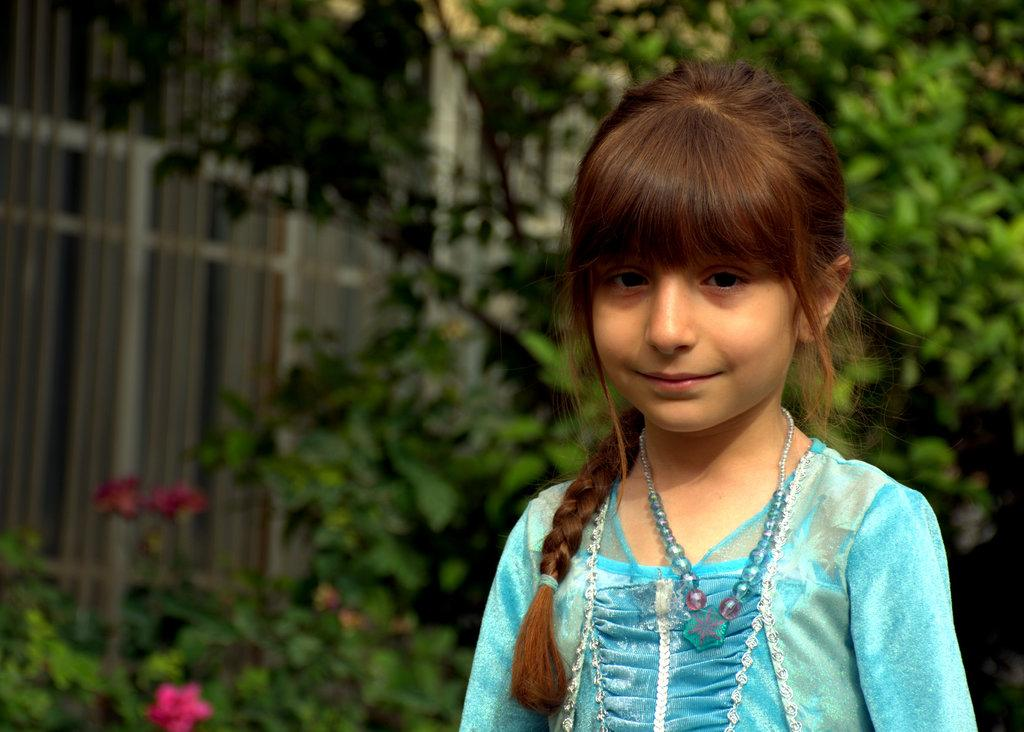Who is present in the image? There is a girl in the image. What is the girl's expression? The girl is smiling. What can be seen in the background of the image? There are plants, flowers, a wall, and trees in the background of the image. What type of brush is the girl using to paint the rainstorm in the image? There is no brush or rainstorm present in the image; it features a girl smiling with a background of plants, flowers, a wall, and trees. 